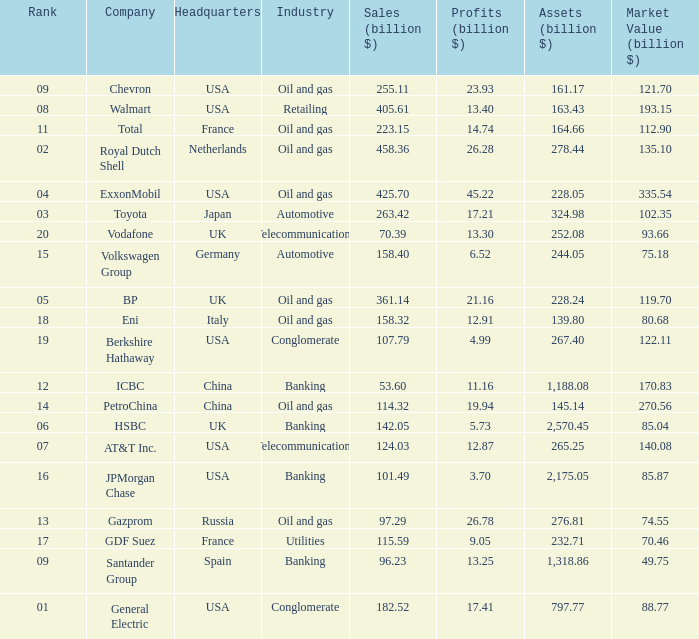Name the Sales (billion $) which have a Company of exxonmobil? 425.7. 